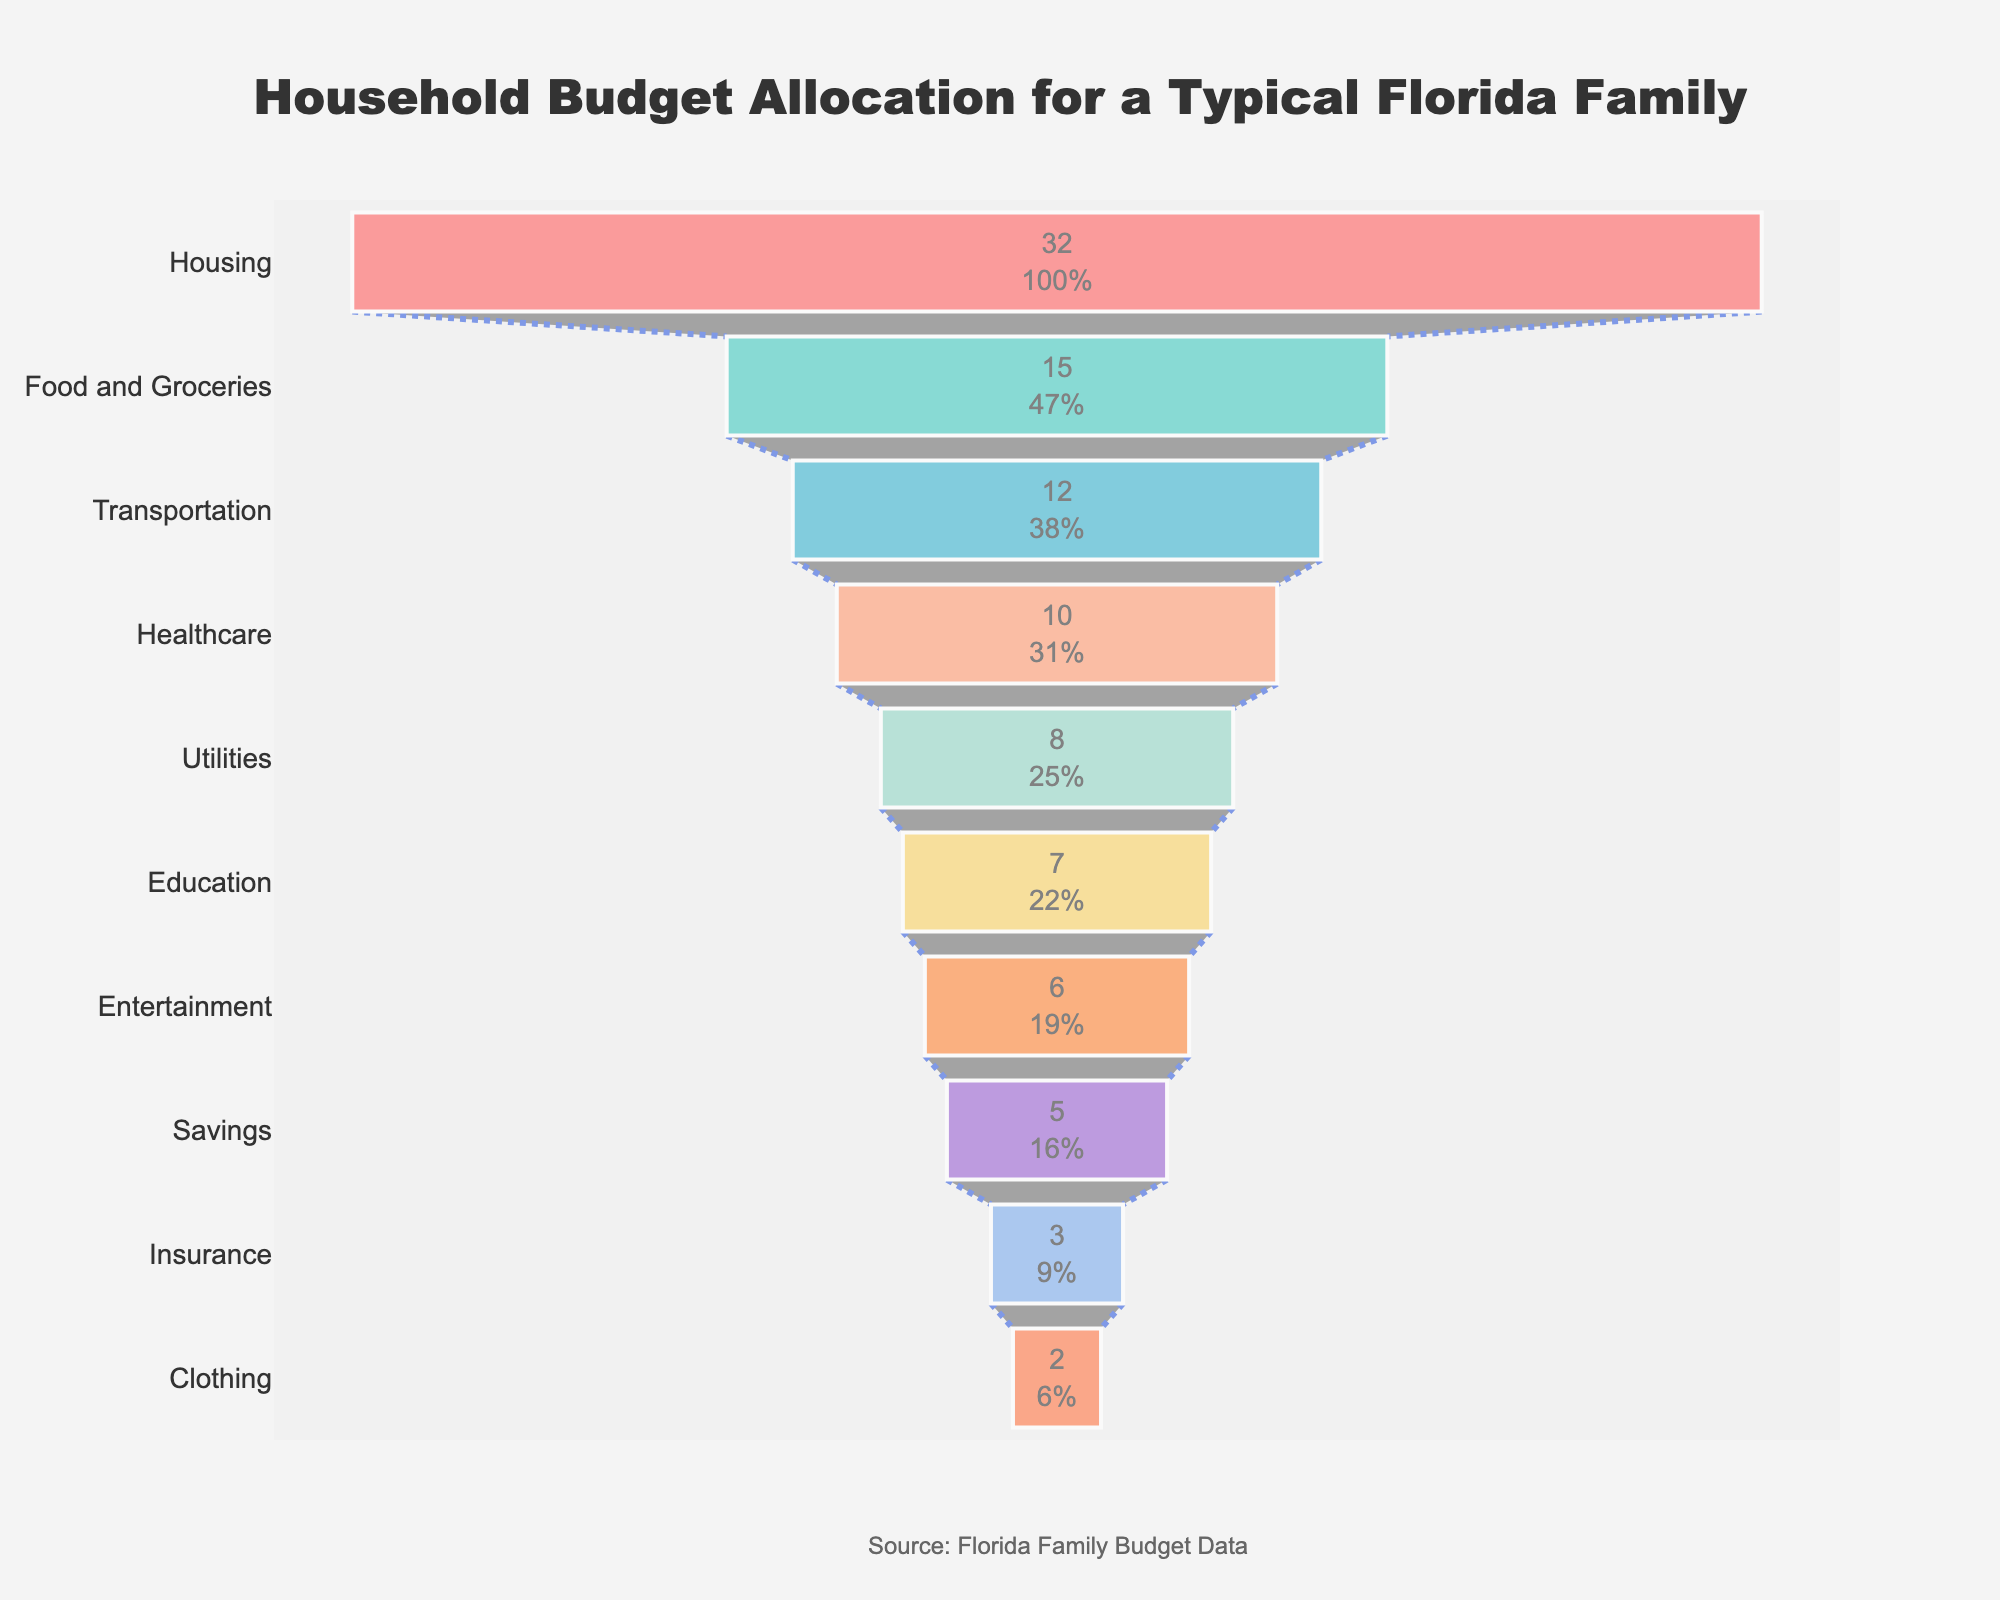What's the title of the funnel chart? The title is displayed prominently at the top of the chart, which is "Household Budget Allocation for a Typical Florida Family".
Answer: Household Budget Allocation for a Typical Florida Family Which category has the highest percentage allocation? Look for the largest segment at the top of the funnel. The "Housing" category has the highest percentage allocation at 32%.
Answer: Housing What is the combined percentage allocation for Food and Groceries and Transportation? Sum the percentages for "Food and Groceries" (15%) and "Transportation" (12%). 15 + 12 = 27%.
Answer: 27% Is the percentage allocation for Healthcare greater than for Education? Compare the percentage for "Healthcare" (10%) with "Education" (7%). Since 10% is greater than 7%, Healthcare has a higher allocation.
Answer: Yes What percentage of the budget is allocated to categories other than Housing, Food and Groceries, and Transportation? Subtract the combined percentage of Housing, Food and Groceries, and Transportation from 100%. 100 - (32 + 15 + 12) = 41%.
Answer: 41% Which categories have an allocation of less than 10%? Identify the categories whose percentages are below 10%: Utilities (8%), Education (7%), Entertainment (6%), Savings (5%), Insurance (3%), and Clothing (2%).
Answer: Utilities, Education, Entertainment, Savings, Insurance, Clothing How much more is allocated to Housing compared to Savings? Subtract the percentage for Savings (5%) from Housing (32%). 32 - 5 = 27%.
Answer: 27% What is the average percentage allocation for all categories? Sum the percentages of all categories and divide by the number of categories. (32 + 15 + 12 + 10 + 8 + 7 + 6 + 5 + 3 + 2)/10 = 10%.
Answer: 10% What categories make up at least 20% of the household budget combined? Identify categories and sum their percentages until at least 20% is reached. Housing (32%) alone exceeds 20%, so it is the only category meeting this criterion.
Answer: Housing What is the difference in percentage allocation between Utilities and Entertainment? Subtract the percentage for Entertainment (6%) from Utilities (8%). 8 - 6 = 2%.
Answer: 2% 